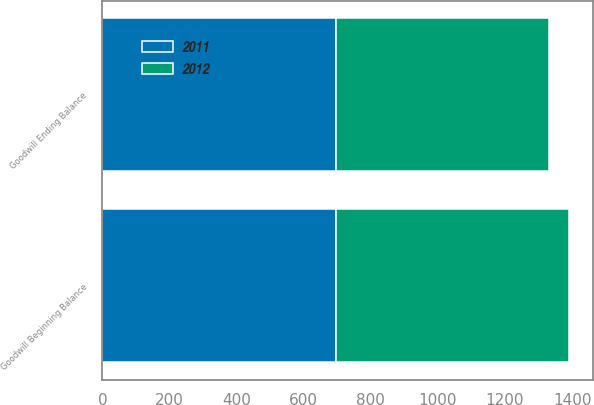Convert chart. <chart><loc_0><loc_0><loc_500><loc_500><stacked_bar_chart><ecel><fcel>Goodwill Beginning Balance<fcel>Goodwill Ending Balance<nl><fcel>2012<fcel>696<fcel>635<nl><fcel>2011<fcel>696<fcel>696<nl></chart> 